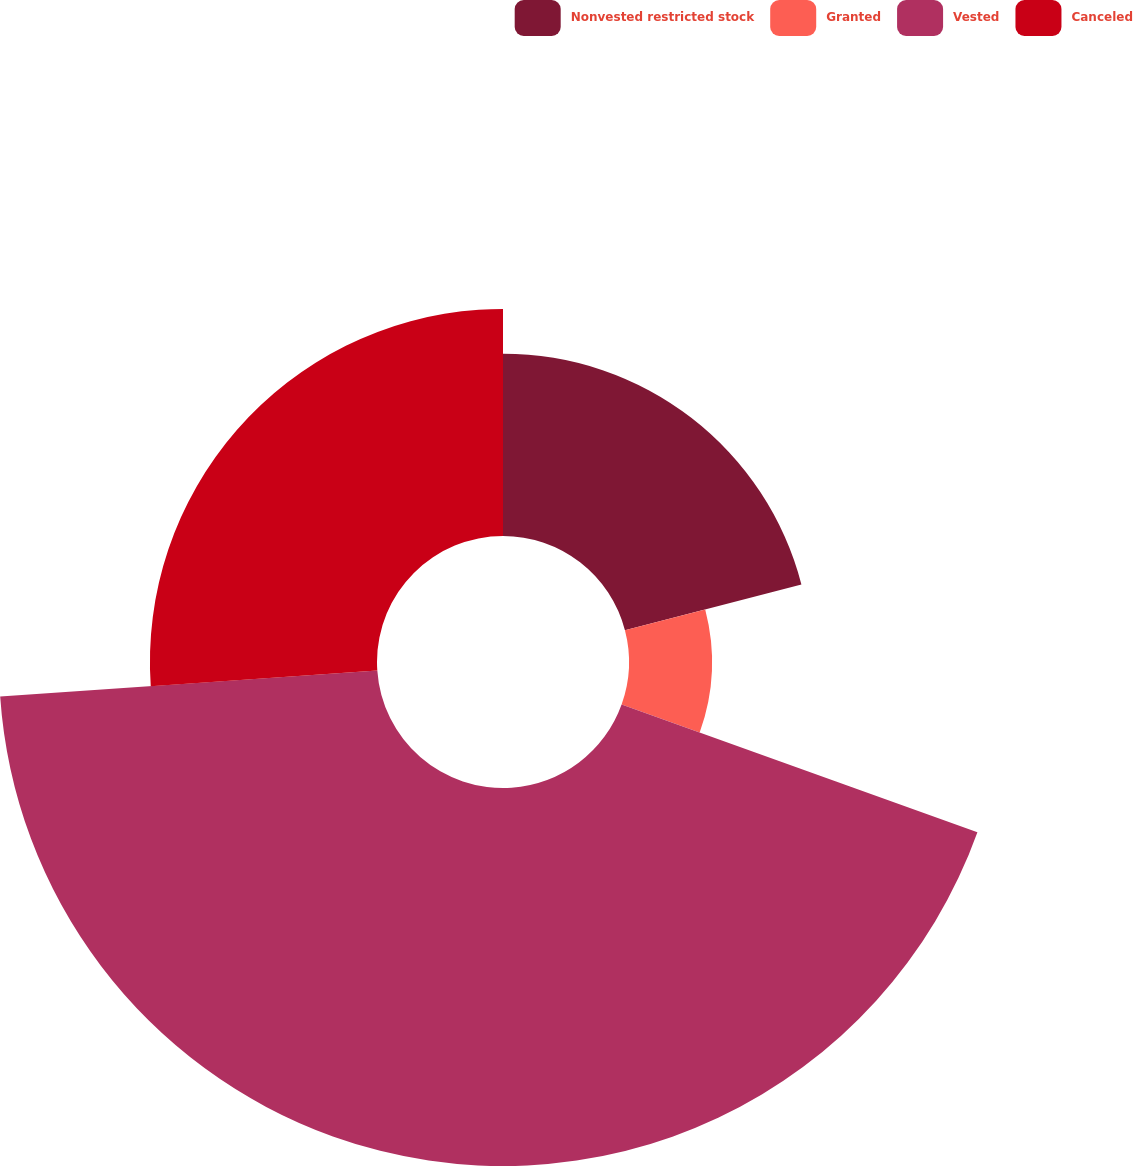Convert chart. <chart><loc_0><loc_0><loc_500><loc_500><pie_chart><fcel>Nonvested restricted stock<fcel>Granted<fcel>Vested<fcel>Canceled<nl><fcel>20.95%<fcel>9.53%<fcel>43.43%<fcel>26.09%<nl></chart> 